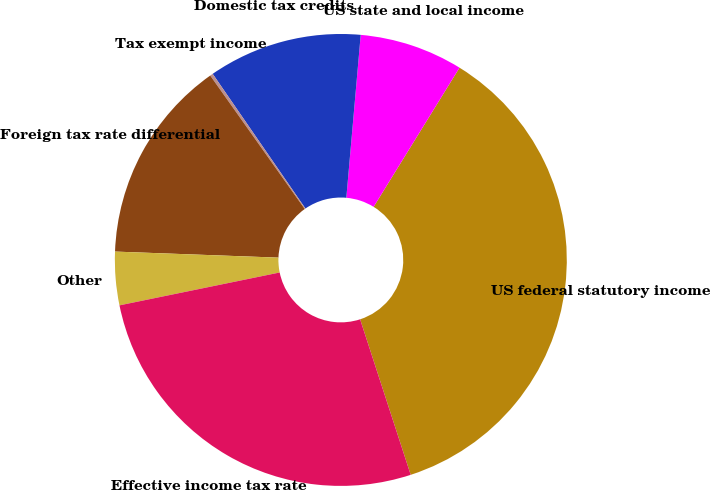Convert chart. <chart><loc_0><loc_0><loc_500><loc_500><pie_chart><fcel>US federal statutory income<fcel>US state and local income<fcel>Domestic tax credits<fcel>Tax exempt income<fcel>Foreign tax rate differential<fcel>Other<fcel>Effective income tax rate<nl><fcel>36.19%<fcel>7.4%<fcel>11.0%<fcel>0.21%<fcel>14.6%<fcel>3.81%<fcel>26.78%<nl></chart> 